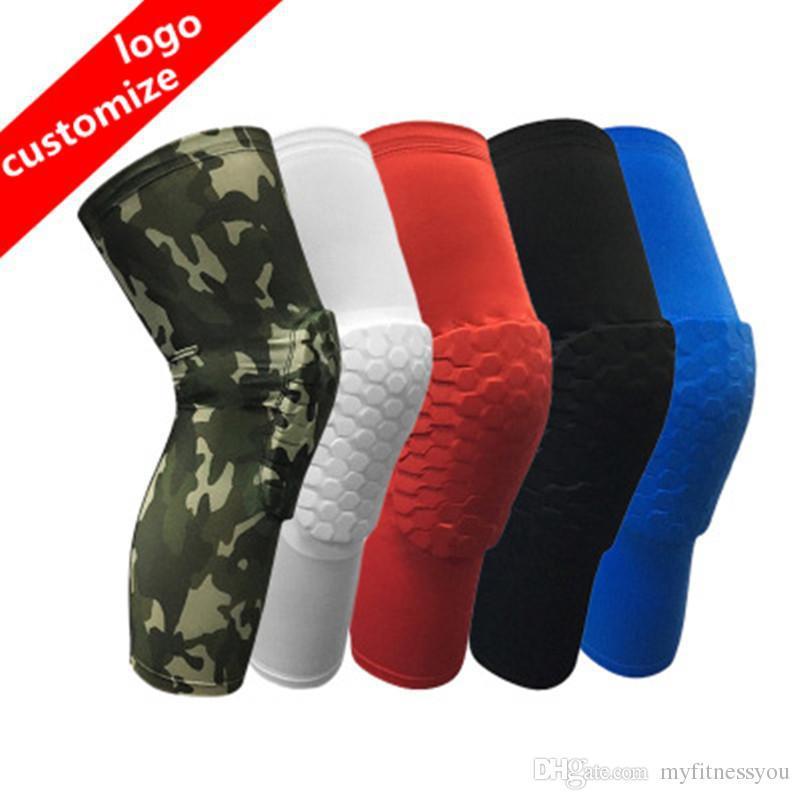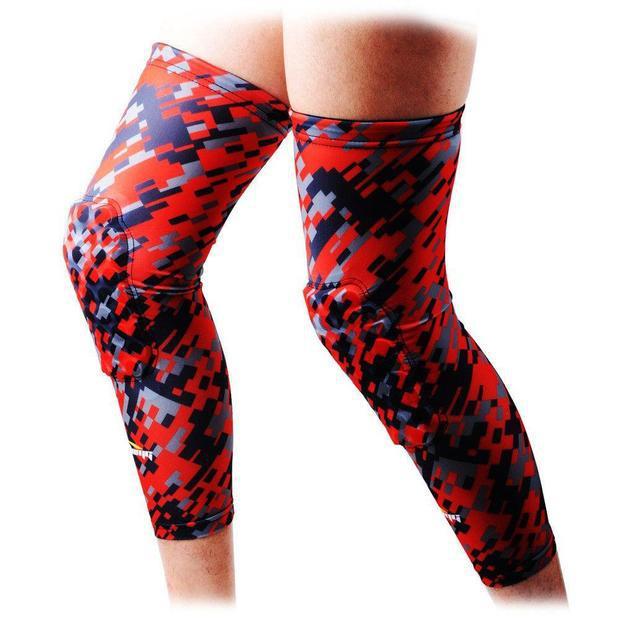The first image is the image on the left, the second image is the image on the right. Analyze the images presented: Is the assertion "In the right image, only the leg on the left is wearing a knee wrap, and the pair of legs are in black shorts." valid? Answer yes or no. No. 